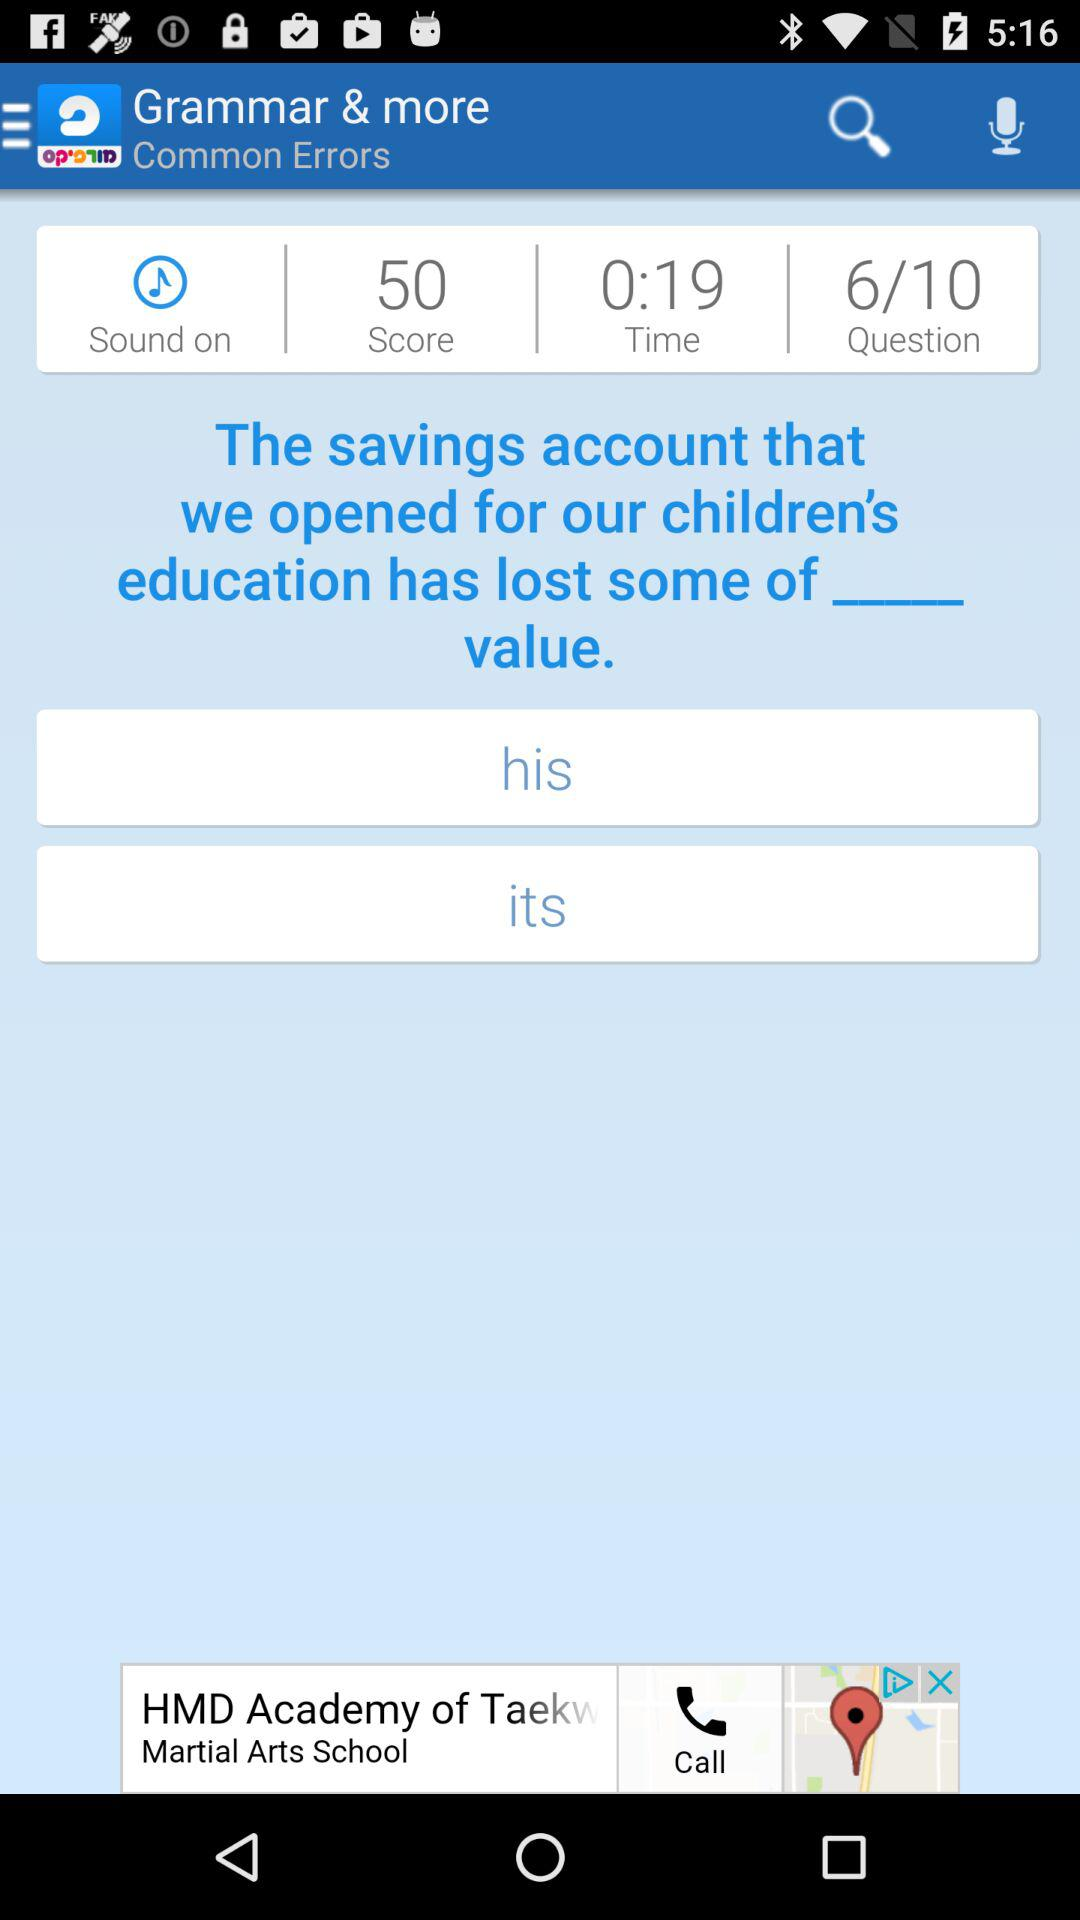What is the status of "Sound"? The status is "on". 